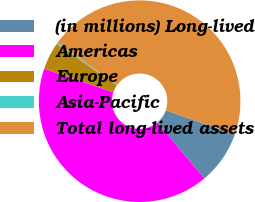Convert chart. <chart><loc_0><loc_0><loc_500><loc_500><pie_chart><fcel>(in millions) Long-lived<fcel>Americas<fcel>Europe<fcel>Asia-Pacific<fcel>Total long-lived assets<nl><fcel>8.57%<fcel>41.32%<fcel>4.4%<fcel>0.23%<fcel>45.49%<nl></chart> 